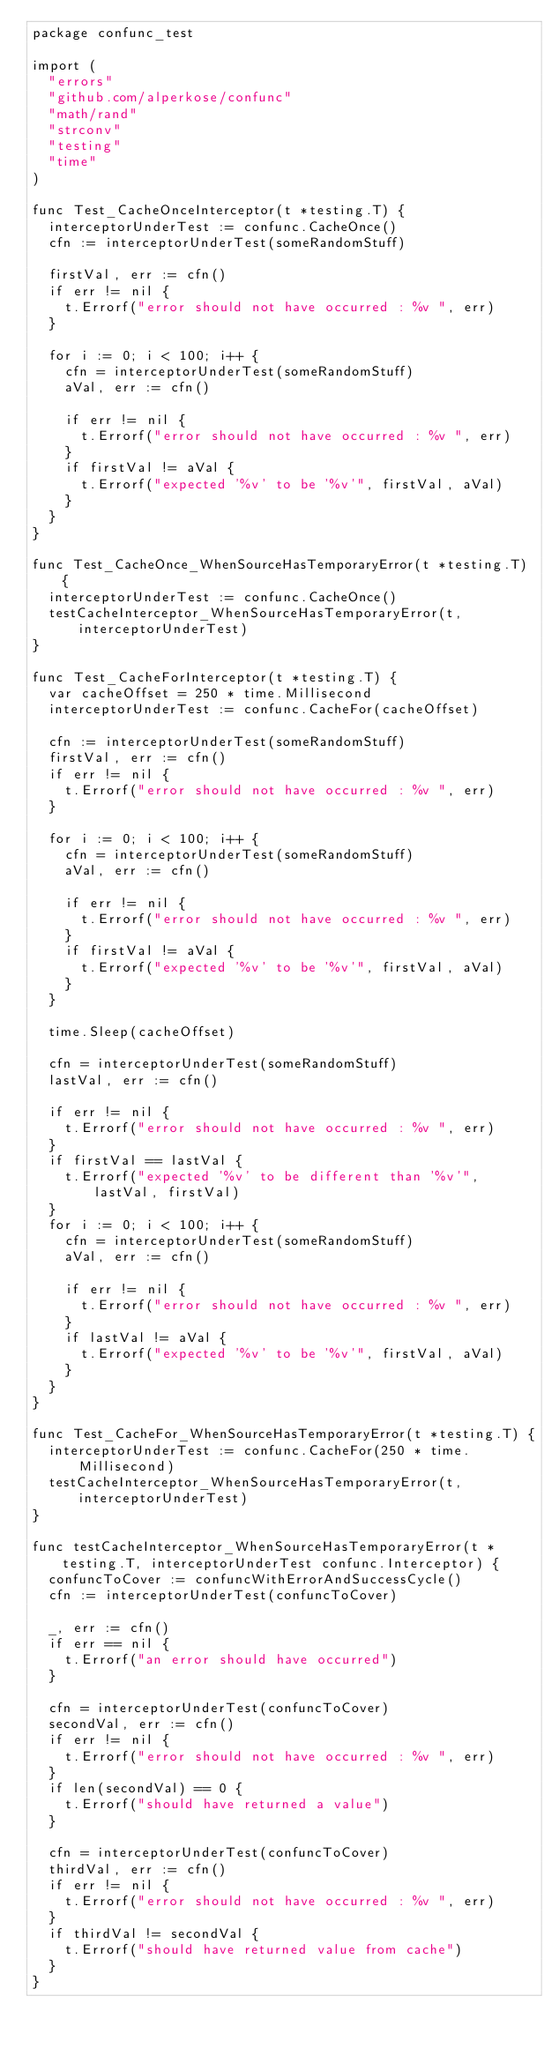Convert code to text. <code><loc_0><loc_0><loc_500><loc_500><_Go_>package confunc_test

import (
	"errors"
	"github.com/alperkose/confunc"
	"math/rand"
	"strconv"
	"testing"
	"time"
)

func Test_CacheOnceInterceptor(t *testing.T) {
	interceptorUnderTest := confunc.CacheOnce()
	cfn := interceptorUnderTest(someRandomStuff)

	firstVal, err := cfn()
	if err != nil {
		t.Errorf("error should not have occurred : %v ", err)
	}

	for i := 0; i < 100; i++ {
		cfn = interceptorUnderTest(someRandomStuff)
		aVal, err := cfn()

		if err != nil {
			t.Errorf("error should not have occurred : %v ", err)
		}
		if firstVal != aVal {
			t.Errorf("expected '%v' to be '%v'", firstVal, aVal)
		}
	}
}

func Test_CacheOnce_WhenSourceHasTemporaryError(t *testing.T) {
	interceptorUnderTest := confunc.CacheOnce()
	testCacheInterceptor_WhenSourceHasTemporaryError(t, interceptorUnderTest)
}

func Test_CacheForInterceptor(t *testing.T) {
	var cacheOffset = 250 * time.Millisecond
	interceptorUnderTest := confunc.CacheFor(cacheOffset)

	cfn := interceptorUnderTest(someRandomStuff)
	firstVal, err := cfn()
	if err != nil {
		t.Errorf("error should not have occurred : %v ", err)
	}

	for i := 0; i < 100; i++ {
		cfn = interceptorUnderTest(someRandomStuff)
		aVal, err := cfn()

		if err != nil {
			t.Errorf("error should not have occurred : %v ", err)
		}
		if firstVal != aVal {
			t.Errorf("expected '%v' to be '%v'", firstVal, aVal)
		}
	}

	time.Sleep(cacheOffset)

	cfn = interceptorUnderTest(someRandomStuff)
	lastVal, err := cfn()

	if err != nil {
		t.Errorf("error should not have occurred : %v ", err)
	}
	if firstVal == lastVal {
		t.Errorf("expected '%v' to be different than '%v'", lastVal, firstVal)
	}
	for i := 0; i < 100; i++ {
		cfn = interceptorUnderTest(someRandomStuff)
		aVal, err := cfn()

		if err != nil {
			t.Errorf("error should not have occurred : %v ", err)
		}
		if lastVal != aVal {
			t.Errorf("expected '%v' to be '%v'", firstVal, aVal)
		}
	}
}

func Test_CacheFor_WhenSourceHasTemporaryError(t *testing.T) {
	interceptorUnderTest := confunc.CacheFor(250 * time.Millisecond)
	testCacheInterceptor_WhenSourceHasTemporaryError(t, interceptorUnderTest)
}

func testCacheInterceptor_WhenSourceHasTemporaryError(t *testing.T, interceptorUnderTest confunc.Interceptor) {
	confuncToCover := confuncWithErrorAndSuccessCycle()
	cfn := interceptorUnderTest(confuncToCover)

	_, err := cfn()
	if err == nil {
		t.Errorf("an error should have occurred")
	}

	cfn = interceptorUnderTest(confuncToCover)
	secondVal, err := cfn()
	if err != nil {
		t.Errorf("error should not have occurred : %v ", err)
	}
	if len(secondVal) == 0 {
		t.Errorf("should have returned a value")
	}

	cfn = interceptorUnderTest(confuncToCover)
	thirdVal, err := cfn()
	if err != nil {
		t.Errorf("error should not have occurred : %v ", err)
	}
	if thirdVal != secondVal {
		t.Errorf("should have returned value from cache")
	}
}
</code> 